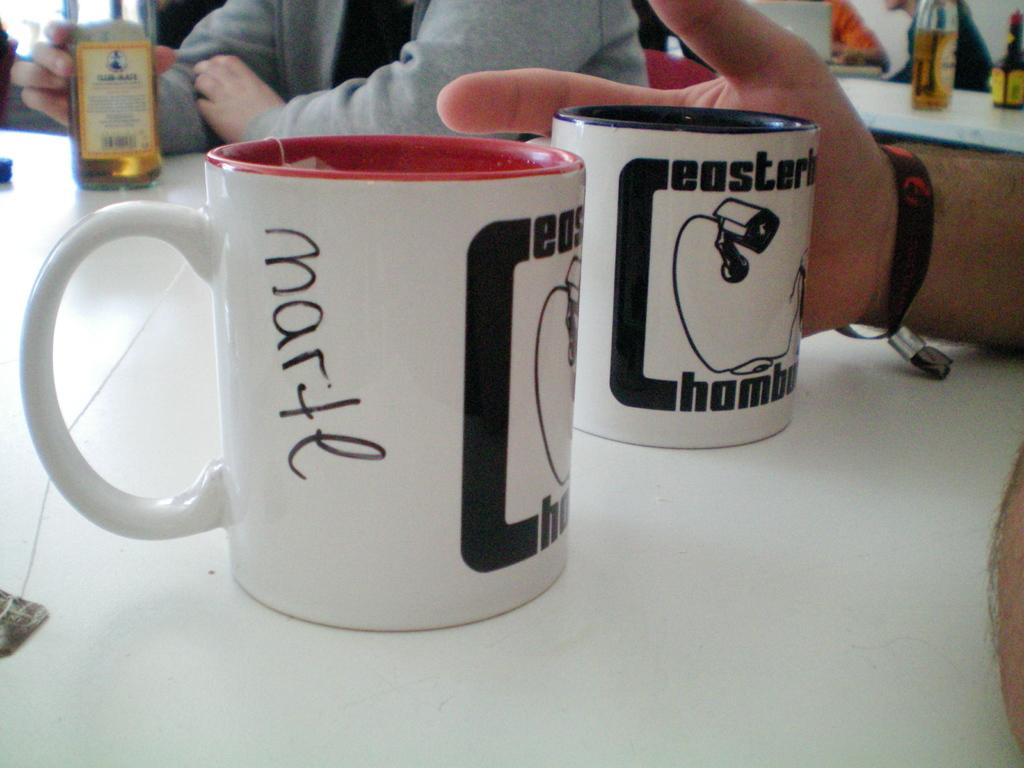<image>
Share a concise interpretation of the image provided. Two white cups on a table with one that says "MARTE" on the side. 